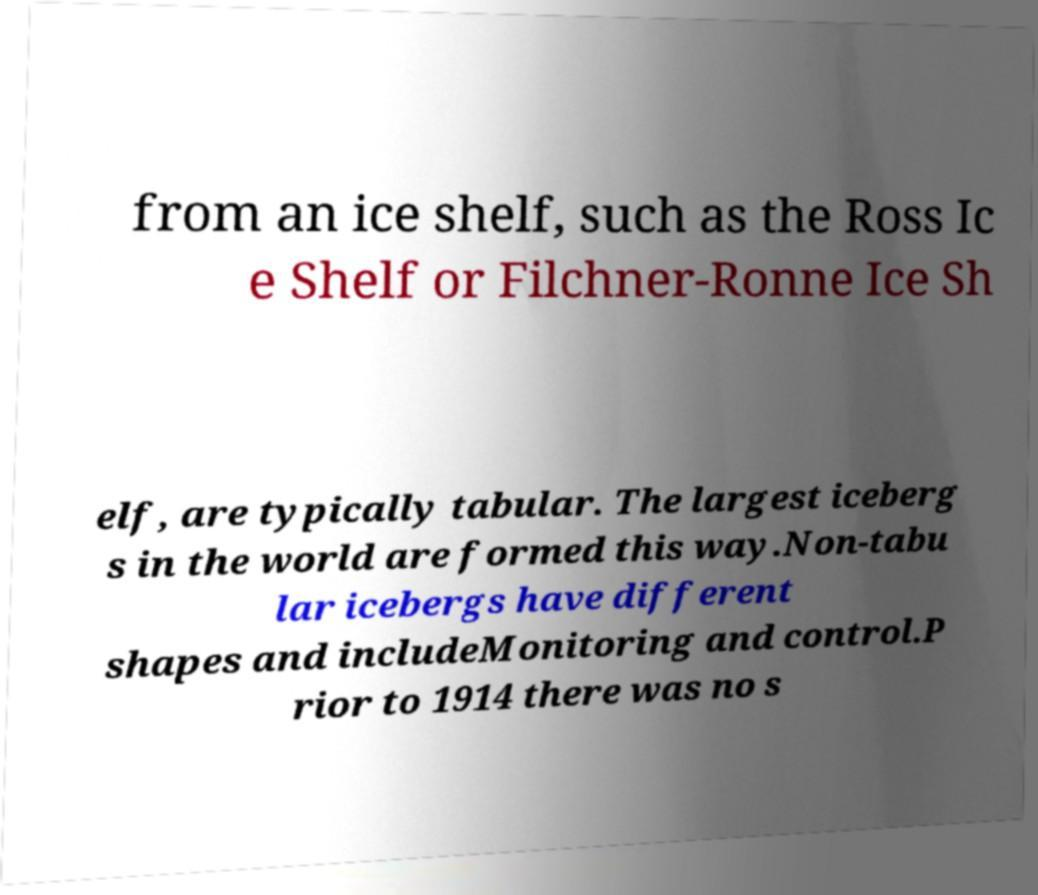Please identify and transcribe the text found in this image. from an ice shelf, such as the Ross Ic e Shelf or Filchner-Ronne Ice Sh elf, are typically tabular. The largest iceberg s in the world are formed this way.Non-tabu lar icebergs have different shapes and includeMonitoring and control.P rior to 1914 there was no s 